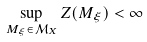<formula> <loc_0><loc_0><loc_500><loc_500>\sup _ { M _ { \xi } \in \mathcal { M } _ { X } } Z ( M _ { \xi } ) < \infty</formula> 